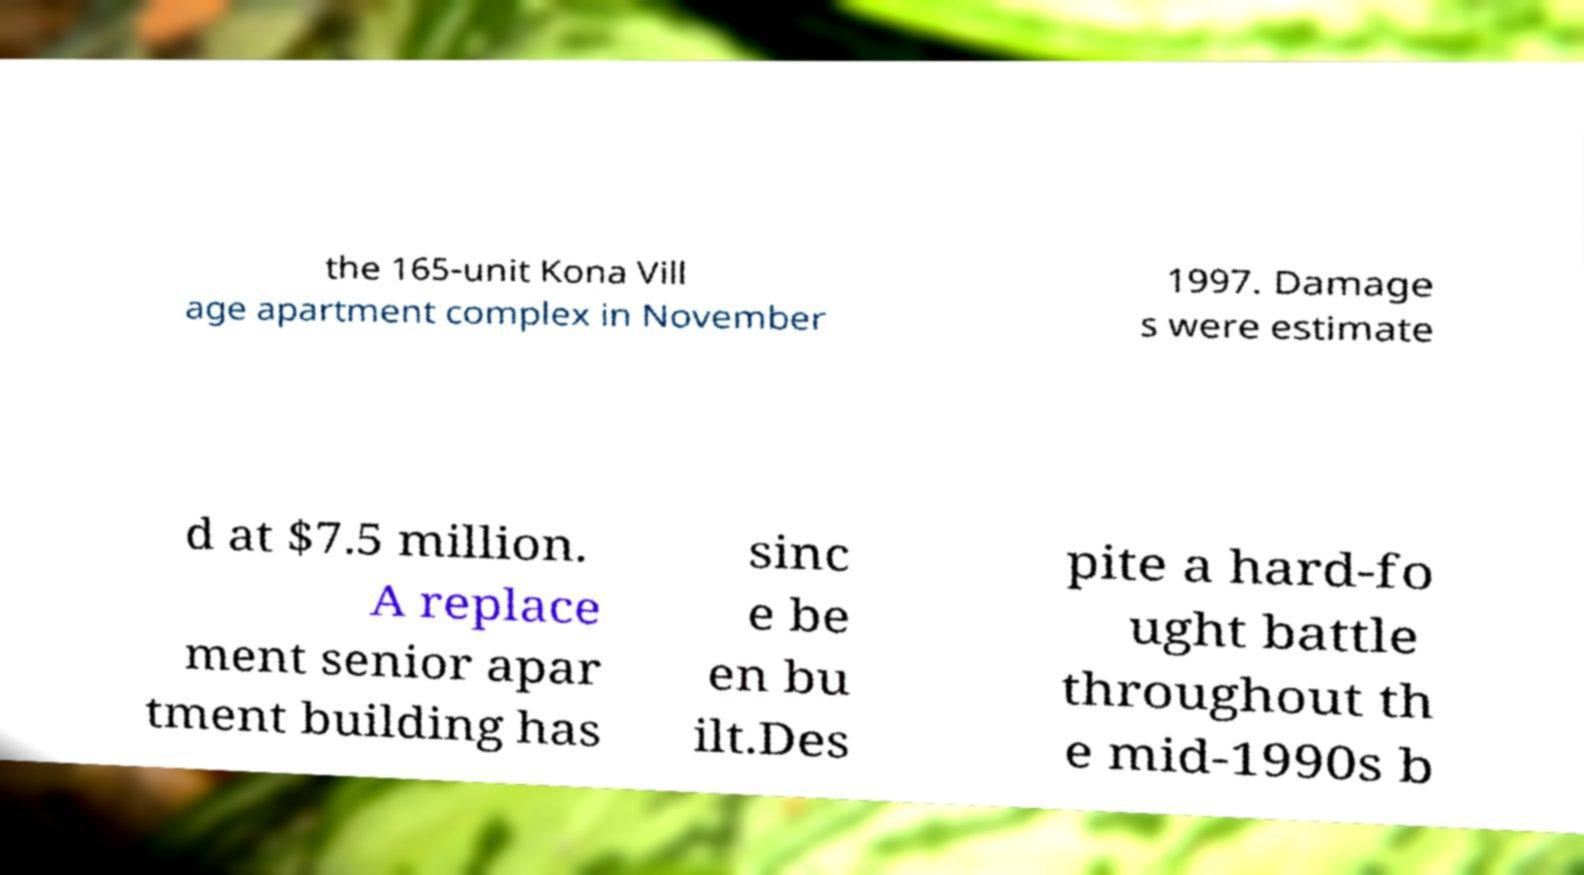Could you extract and type out the text from this image? the 165-unit Kona Vill age apartment complex in November 1997. Damage s were estimate d at $7.5 million. A replace ment senior apar tment building has sinc e be en bu ilt.Des pite a hard-fo ught battle throughout th e mid-1990s b 